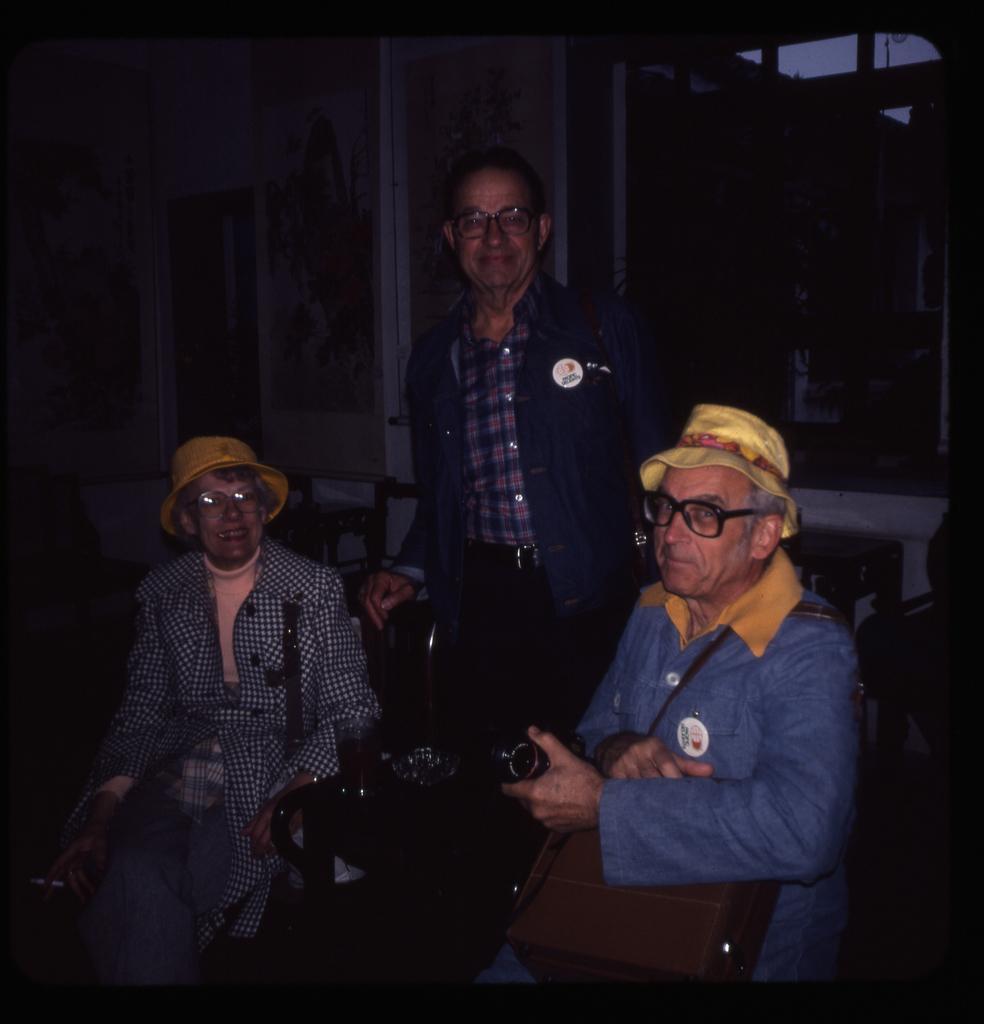How would you summarize this image in a sentence or two? In this picture, I can see three people towards left there is a women an old women who is sitting and wearing a spicks and towards right there is a old men, Who is wearing hat, specks and holding a camera after that i can see a person standing and wearing a specs. 